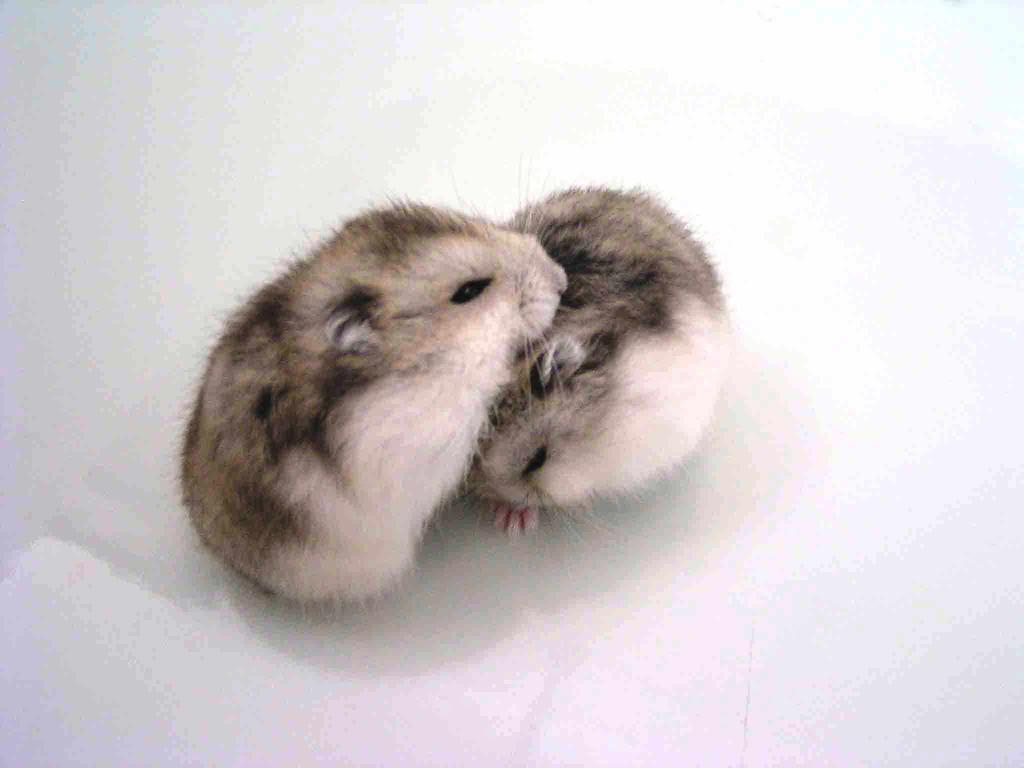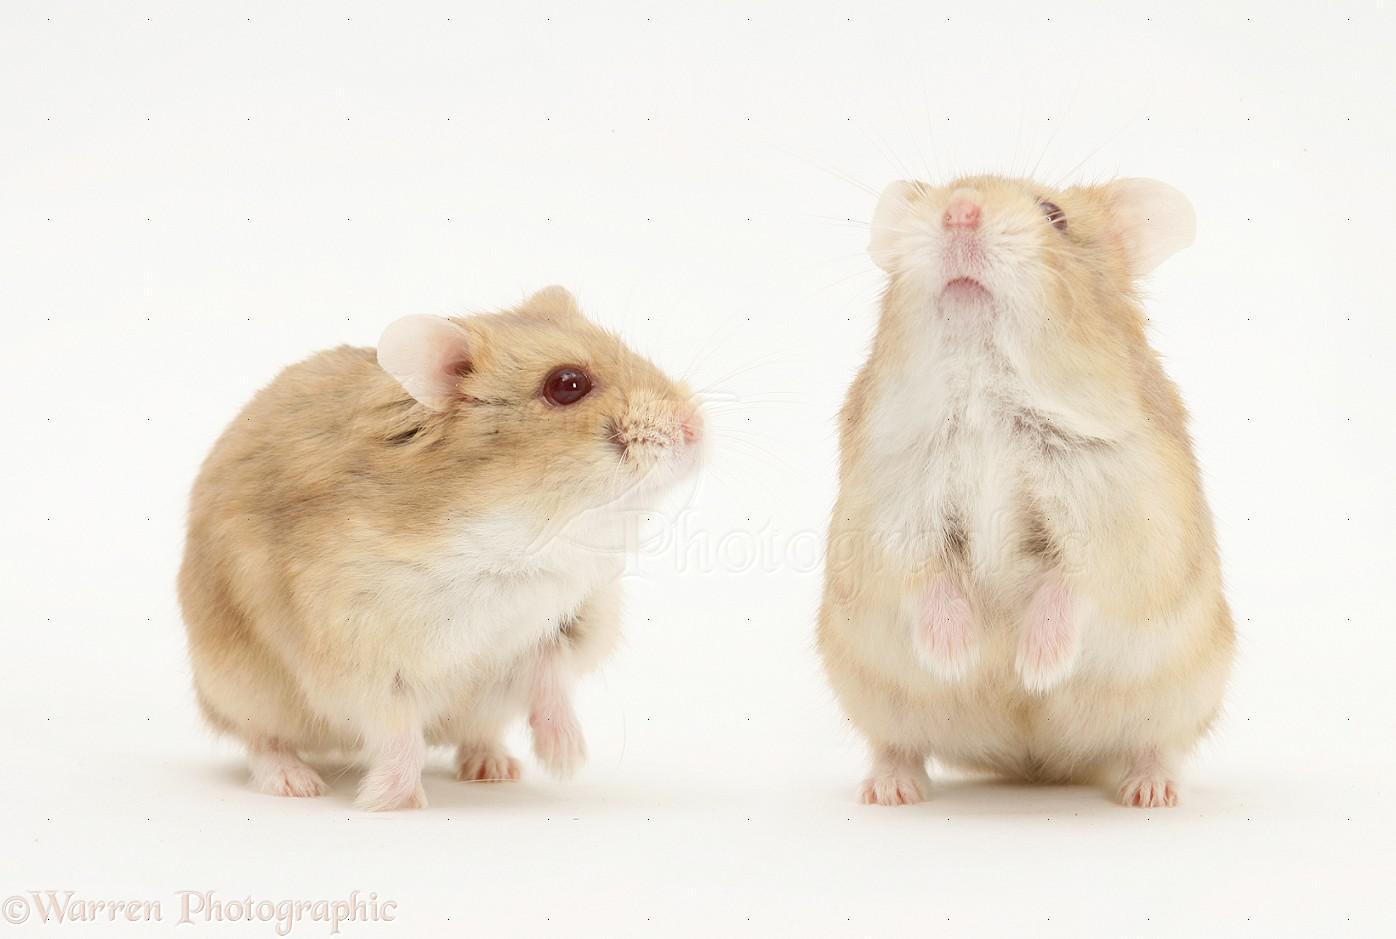The first image is the image on the left, the second image is the image on the right. Analyze the images presented: Is the assertion "Each image contains two pet rodents, and at least one image includes a rodent sitting upright." valid? Answer yes or no. Yes. The first image is the image on the left, the second image is the image on the right. Analyze the images presented: Is the assertion "The rodents in the image on the left are face to face." valid? Answer yes or no. Yes. 